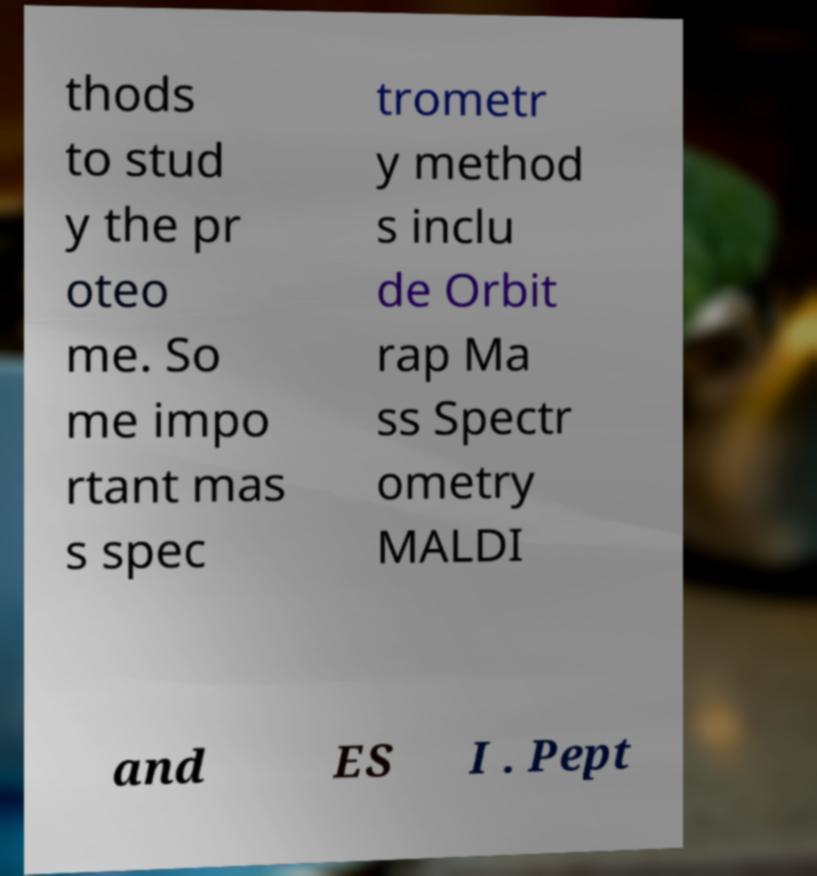For documentation purposes, I need the text within this image transcribed. Could you provide that? thods to stud y the pr oteo me. So me impo rtant mas s spec trometr y method s inclu de Orbit rap Ma ss Spectr ometry MALDI and ES I . Pept 